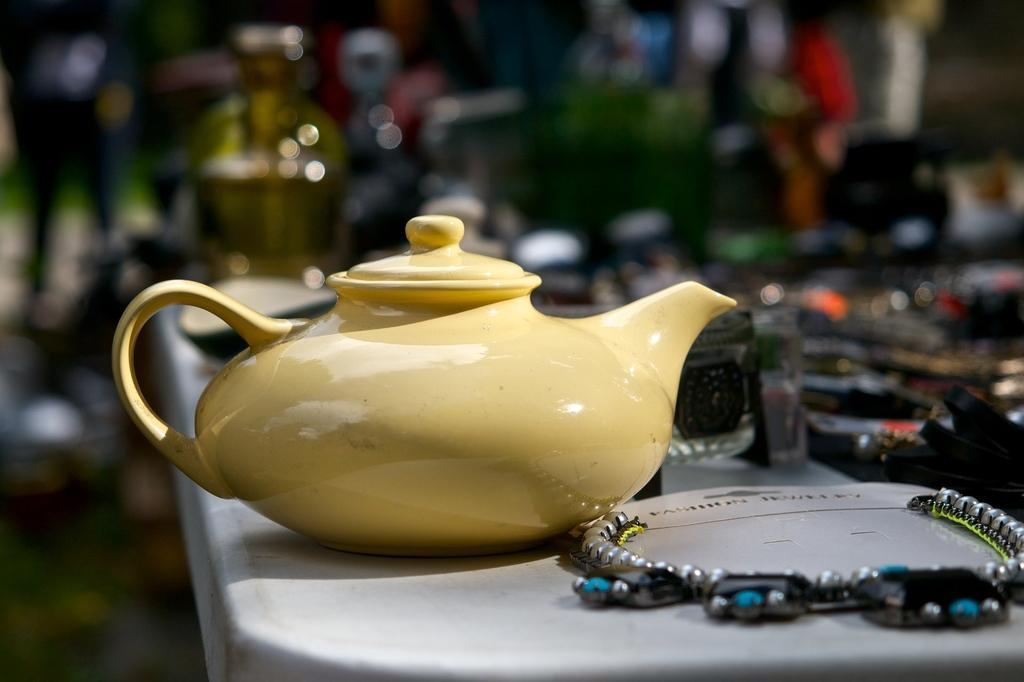What object is the main subject of the image? There is a pot in the image. What color is the pot? The pot is light yellow in color. What other object can be seen in the image? There is a neck chain in the image. Can you describe the background of the image? The background of the image is blurred. What type of credit can be seen being given to the creator of the pot in the image? There is no credit or creator mentioned in the image, as it only features a pot and a neck chain. 